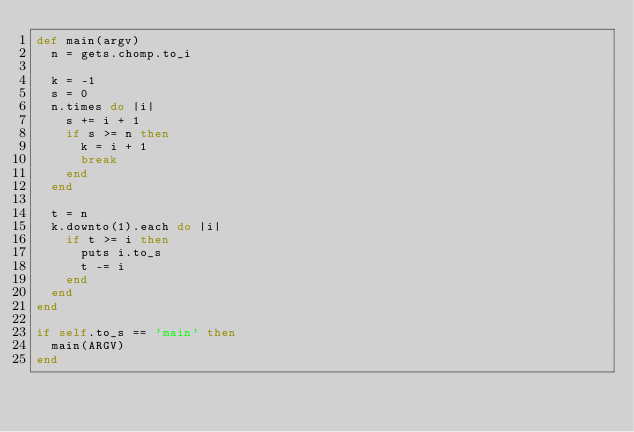Convert code to text. <code><loc_0><loc_0><loc_500><loc_500><_Ruby_>def main(argv)
  n = gets.chomp.to_i

  k = -1
  s = 0
  n.times do |i|
    s += i + 1
    if s >= n then
      k = i + 1
      break
    end
  end
  
  t = n
  k.downto(1).each do |i|
    if t >= i then
      puts i.to_s
      t -= i
    end
  end
end

if self.to_s == 'main' then
  main(ARGV)
end</code> 